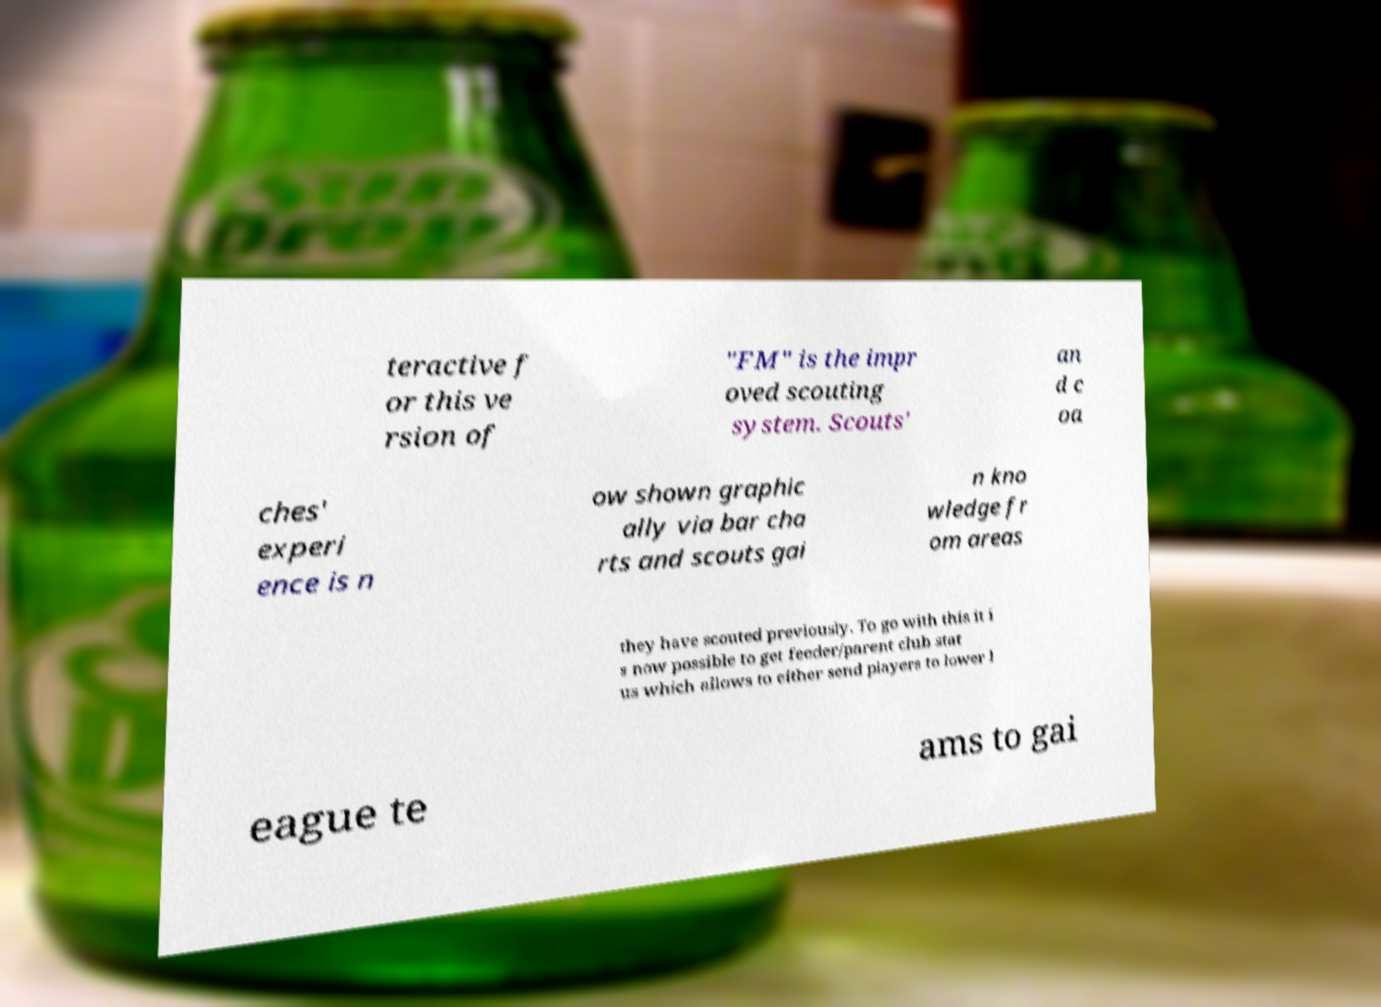Can you read and provide the text displayed in the image?This photo seems to have some interesting text. Can you extract and type it out for me? teractive f or this ve rsion of "FM" is the impr oved scouting system. Scouts' an d c oa ches' experi ence is n ow shown graphic ally via bar cha rts and scouts gai n kno wledge fr om areas they have scouted previously. To go with this it i s now possible to get feeder/parent club stat us which allows to either send players to lower l eague te ams to gai 